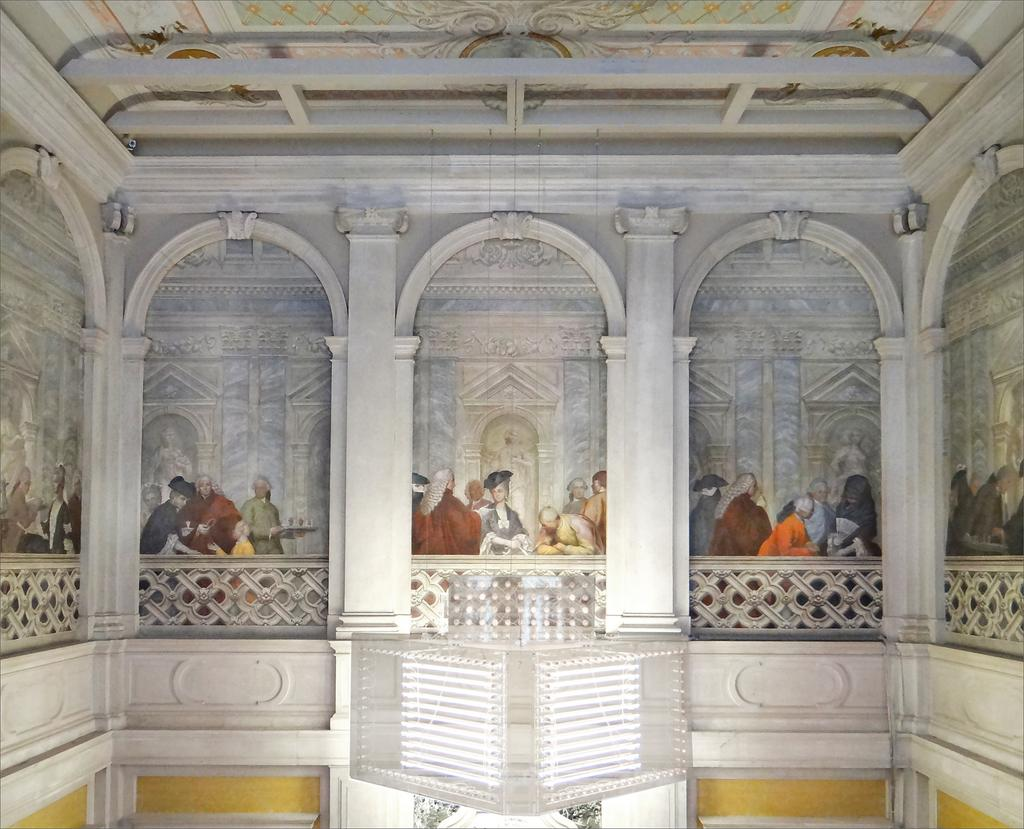What is the main subject of the image? There is a painting in the image. Where is the image taken? The image shows an inside view of a building. Can you describe the people in the image? There are people in the image. What architectural features can be seen in the image? There are pillars and railings in the image. What type of bread is being served to the people in the image? There is no bread present in the image; it features a painting and people in an indoor setting with pillars and railings. 